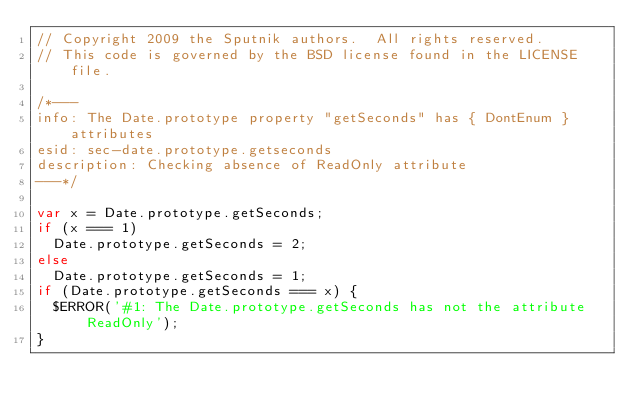<code> <loc_0><loc_0><loc_500><loc_500><_JavaScript_>// Copyright 2009 the Sputnik authors.  All rights reserved.
// This code is governed by the BSD license found in the LICENSE file.

/*---
info: The Date.prototype property "getSeconds" has { DontEnum } attributes
esid: sec-date.prototype.getseconds
description: Checking absence of ReadOnly attribute
---*/

var x = Date.prototype.getSeconds;
if (x === 1)
  Date.prototype.getSeconds = 2;
else
  Date.prototype.getSeconds = 1;
if (Date.prototype.getSeconds === x) {
  $ERROR('#1: The Date.prototype.getSeconds has not the attribute ReadOnly');
}
</code> 